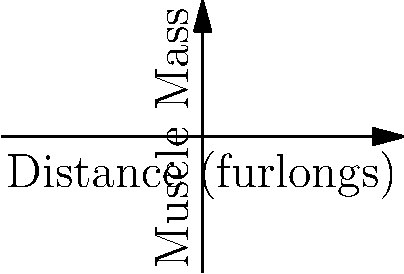Based on the graph showing the relationship between muscle mass and racing distance for sprinters (blue) and stayers (red), which type of horse is likely to have a higher muscle mass at their optimal racing distance, and why is this significant for their performance? To answer this question, let's analyze the graph step-by-step:

1. The graph shows two curves: blue for sprinters and red for stayers.
2. The x-axis represents the racing distance in furlongs, while the y-axis represents muscle mass.
3. The blue curve (sprinters) rises more steeply than the red curve (stayers).
4. The optimal racing distance for sprinters is shown at around 2 furlongs, while for stayers it's around 5 furlongs.
5. At their respective optimal distances:
   - Sprinters have a muscle mass of approximately 3 units
   - Stayers have a muscle mass of approximately 4.5 units

6. This indicates that stayers have a higher muscle mass at their optimal racing distance.

The significance of this difference in muscle mass for performance:

a) Sprinters:
   - Lower muscle mass allows for quick acceleration and high-speed over short distances.
   - Less weight to carry, reducing energy expenditure in short bursts.

b) Stayers:
   - Higher muscle mass provides endurance for longer distances.
   - More slow-twitch muscle fibers, which are efficient for sustained effort.
   - Greater capacity to store glycogen, essential for long-distance energy.

This muscle mass distribution reflects the different physiological demands of sprint and long-distance racing, allowing each type of horse to perform optimally in their specialized distance.
Answer: Stayers; higher muscle mass supports endurance for longer races. 